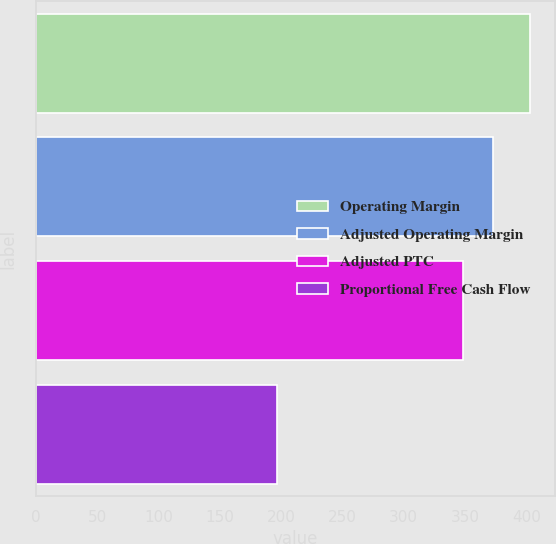Convert chart. <chart><loc_0><loc_0><loc_500><loc_500><bar_chart><fcel>Operating Margin<fcel>Adjusted Operating Margin<fcel>Adjusted PTC<fcel>Proportional Free Cash Flow<nl><fcel>403<fcel>373<fcel>348<fcel>197<nl></chart> 